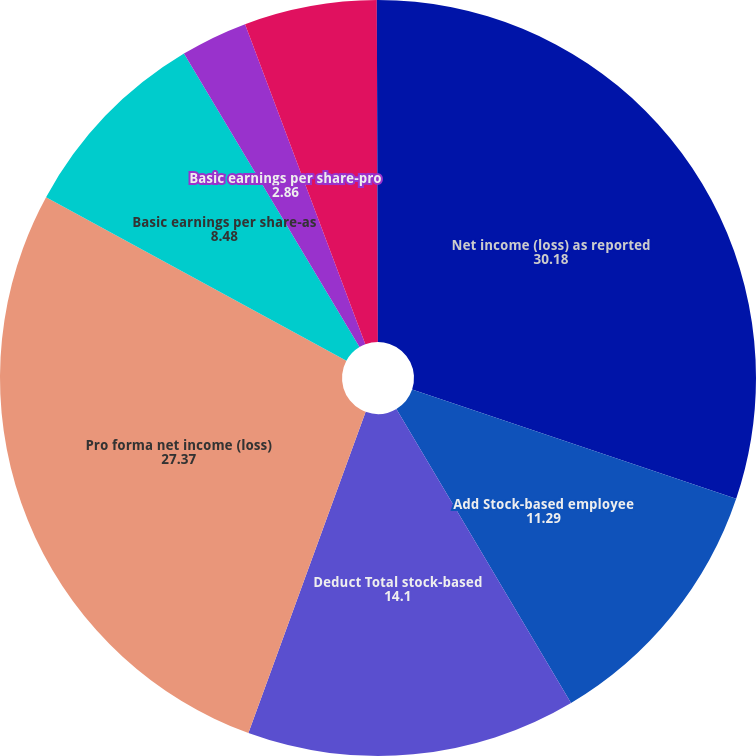Convert chart to OTSL. <chart><loc_0><loc_0><loc_500><loc_500><pie_chart><fcel>Net income (loss) as reported<fcel>Add Stock-based employee<fcel>Deduct Total stock-based<fcel>Pro forma net income (loss)<fcel>Basic earnings per share-as<fcel>Basic earnings per share-pro<fcel>Diluted earnings per share-as<fcel>Diluted earnings per share-pro<nl><fcel>30.18%<fcel>11.29%<fcel>14.1%<fcel>27.37%<fcel>8.48%<fcel>2.86%<fcel>5.67%<fcel>0.05%<nl></chart> 